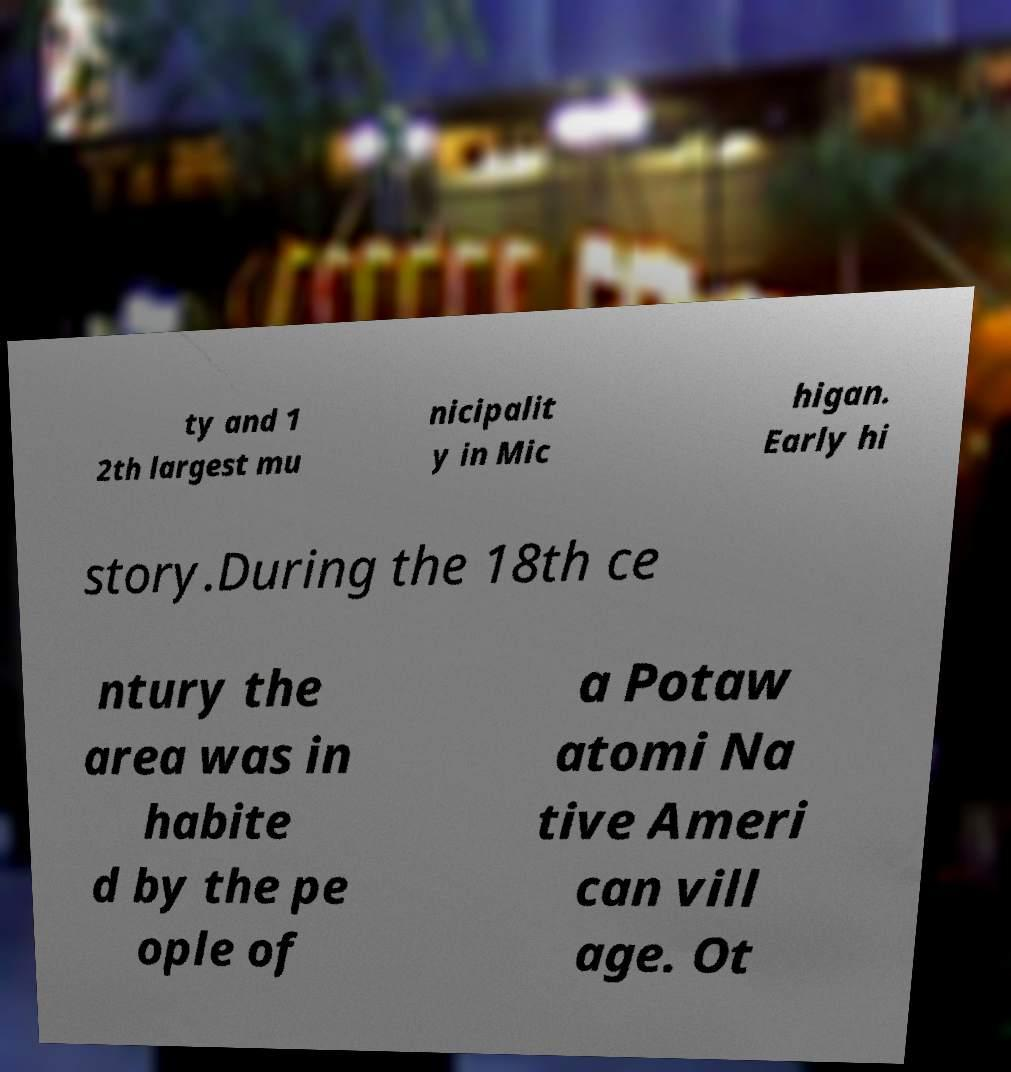Can you accurately transcribe the text from the provided image for me? ty and 1 2th largest mu nicipalit y in Mic higan. Early hi story.During the 18th ce ntury the area was in habite d by the pe ople of a Potaw atomi Na tive Ameri can vill age. Ot 